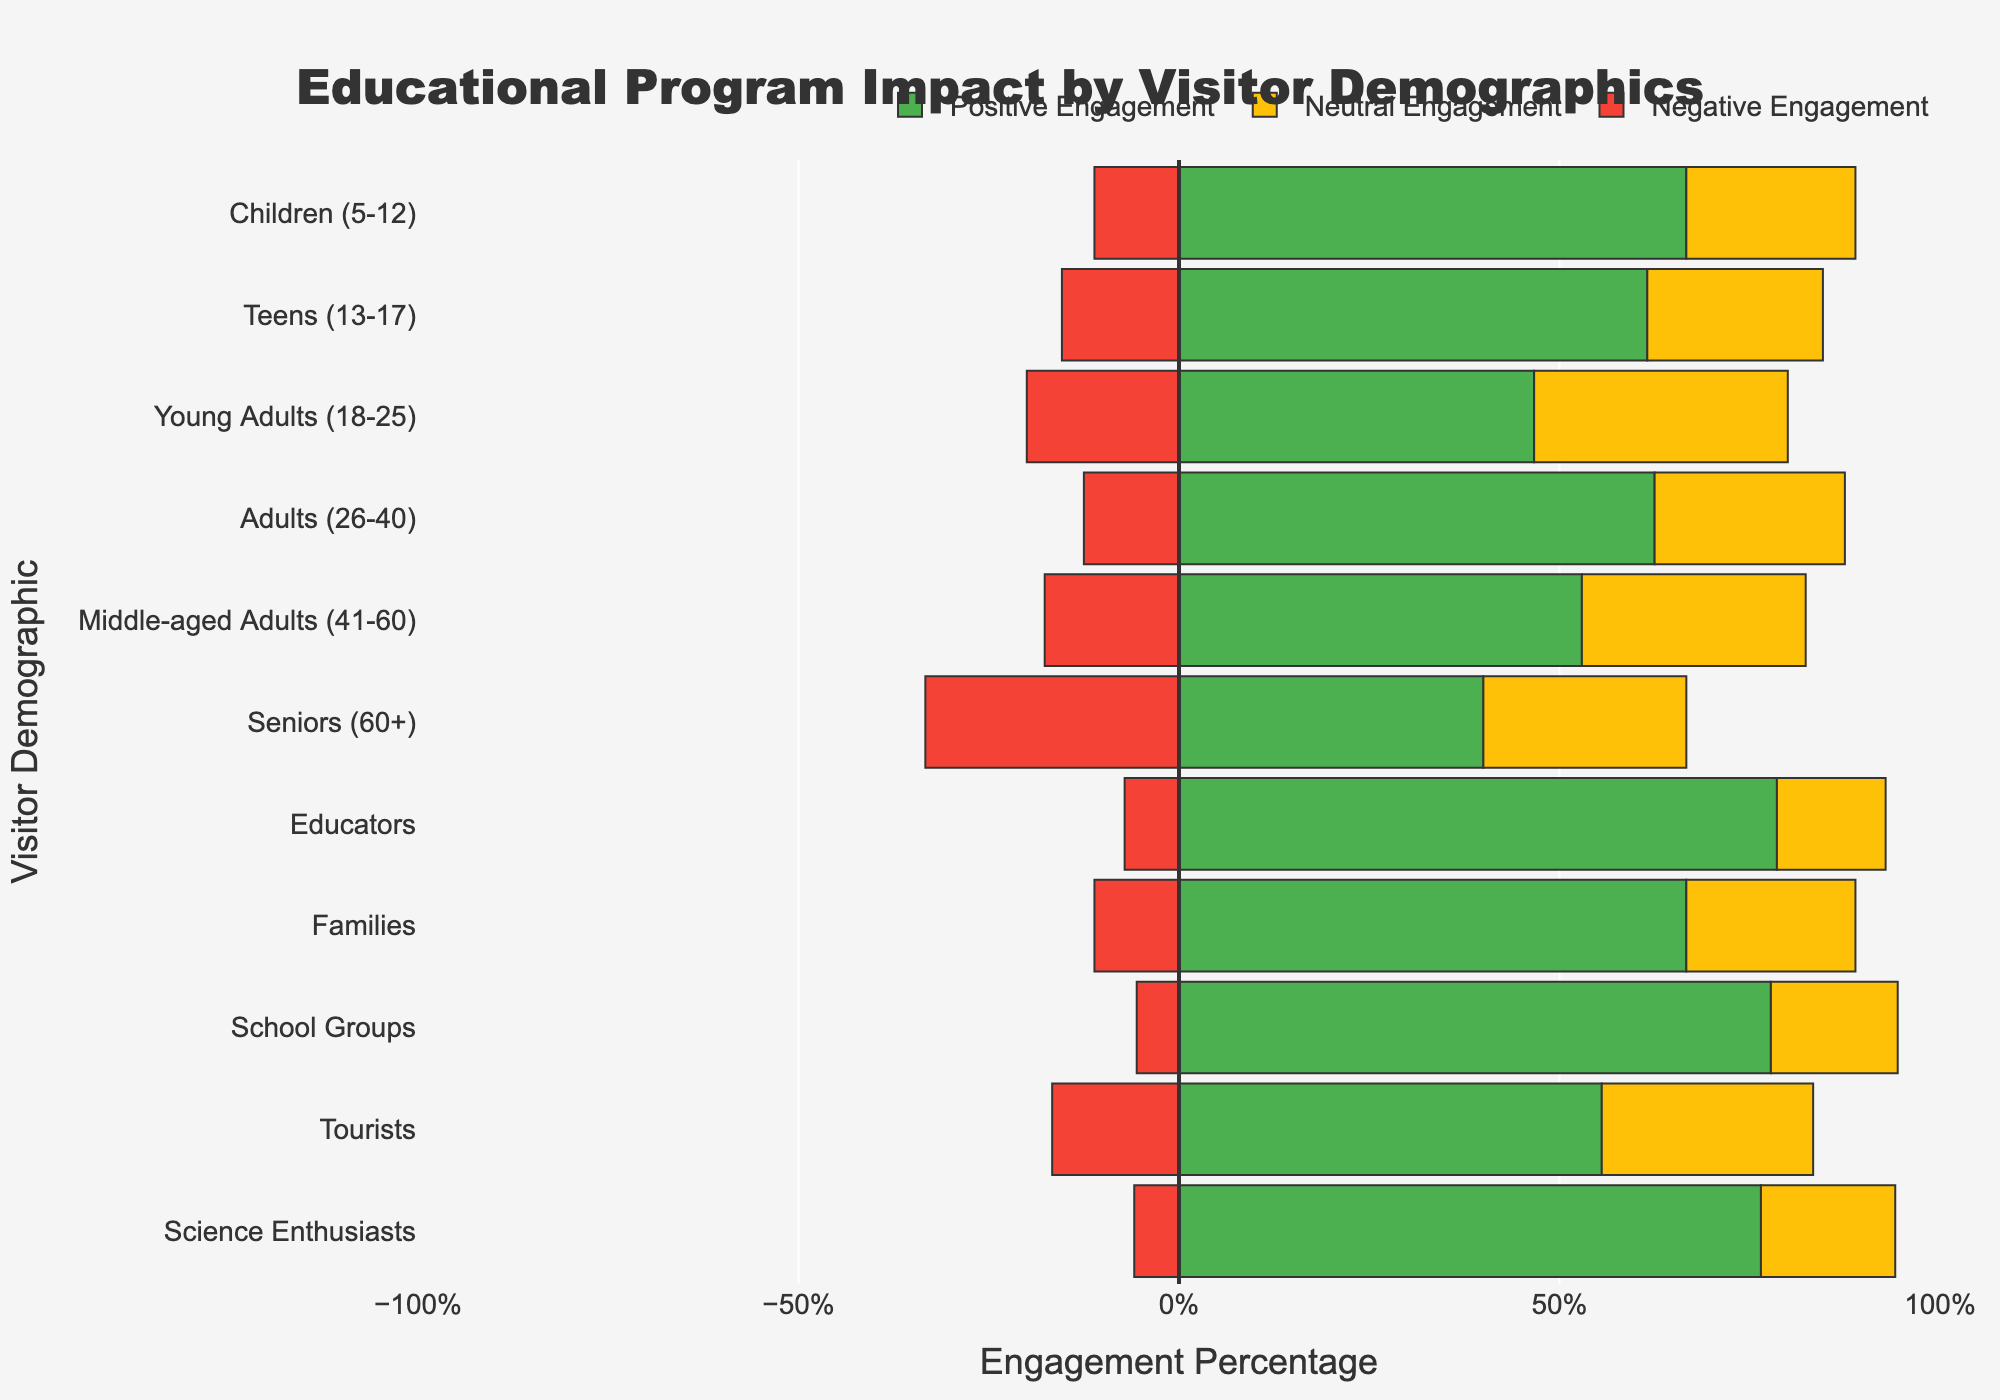Which visitor demographic has the highest percentage of positive engagement? By looking at the length of the green bars, "School Groups" has the longest green bar, indicating the highest percentage of positive engagement.
Answer: School Groups Which groups have more than 50% positive engagement? By examining the green bars, "Educators," "Families," "School Groups," "Tourists," and "Science Enthusiasts" are all greater than 50% positive engagement.
Answer: Educators, Families, School Groups, Tourists, Science Enthusiasts What is the difference in positive engagement percentage between "Children (5-12)" and "Teenagers (13-17)"? The green bar length for "Children (5-12)" is 30%, and for "Teenagers (13-17)" is 40%. Subtracting these gives 40% - 30% = 10%.
Answer: 10% Which visitor demographic has the highest percentage of negative engagement? By observing the length of the red bars, "Seniors (60+)" has the longest red bar, indicating the highest percentage of negative engagement.
Answer: Seniors (60+) What is the combined percentage of positive and neutral engagement for "Young Adults (18-25)"? The green bar (positive) is 35%, and the yellow bar (neutral) is 25%. Adding these gives 35% + 25% = 60%.
Answer: 60% Which demographic has the smallest percentage of negative engagement? By observing the length of the red bars, "Children (5-12)," "Educators," and "Science Enthusiasts" all have the smallest negative engagement at 5%.
Answer: Children (5-12), Educators, Science Enthusiasts How does the positive engagement compare between "Middle-aged Adults (41-60)" and "Young Adults (18-25)"? The green bar for "Middle-aged Adults (41-60)" is 45%, and for "Young Adults (18-25)" is 35%. "Middle-aged Adults" have a higher positive engagement than "Young Adults".
Answer: Middle-aged Adults (41-60) have higher positive engagement Which visitor demographic has a more balanced engagement distribution (i.e., closer to equal percentages across positive, neutral, and negative)? By looking at bar lengths that are closer to equal, "Teens (13-17)" and "Seniors (60+)" have bars that are more balanced across colors.
Answer: Teens (13-17), Seniors (60+) What is the total percentage of neutral and negative engagement for "Families"? The yellow bar (neutral) is 20%, and the red bar (negative) is 10%. Adding these gives 20% + 10% = 30%.
Answer: 30% Which group's engagement has the smallest variation between the three categories? By observing the relative lengths of the bars, "Teens (13-17)" have the most similar lengths of green, yellow, and red bars, showing the smallest variation.
Answer: Teens (13-17) 